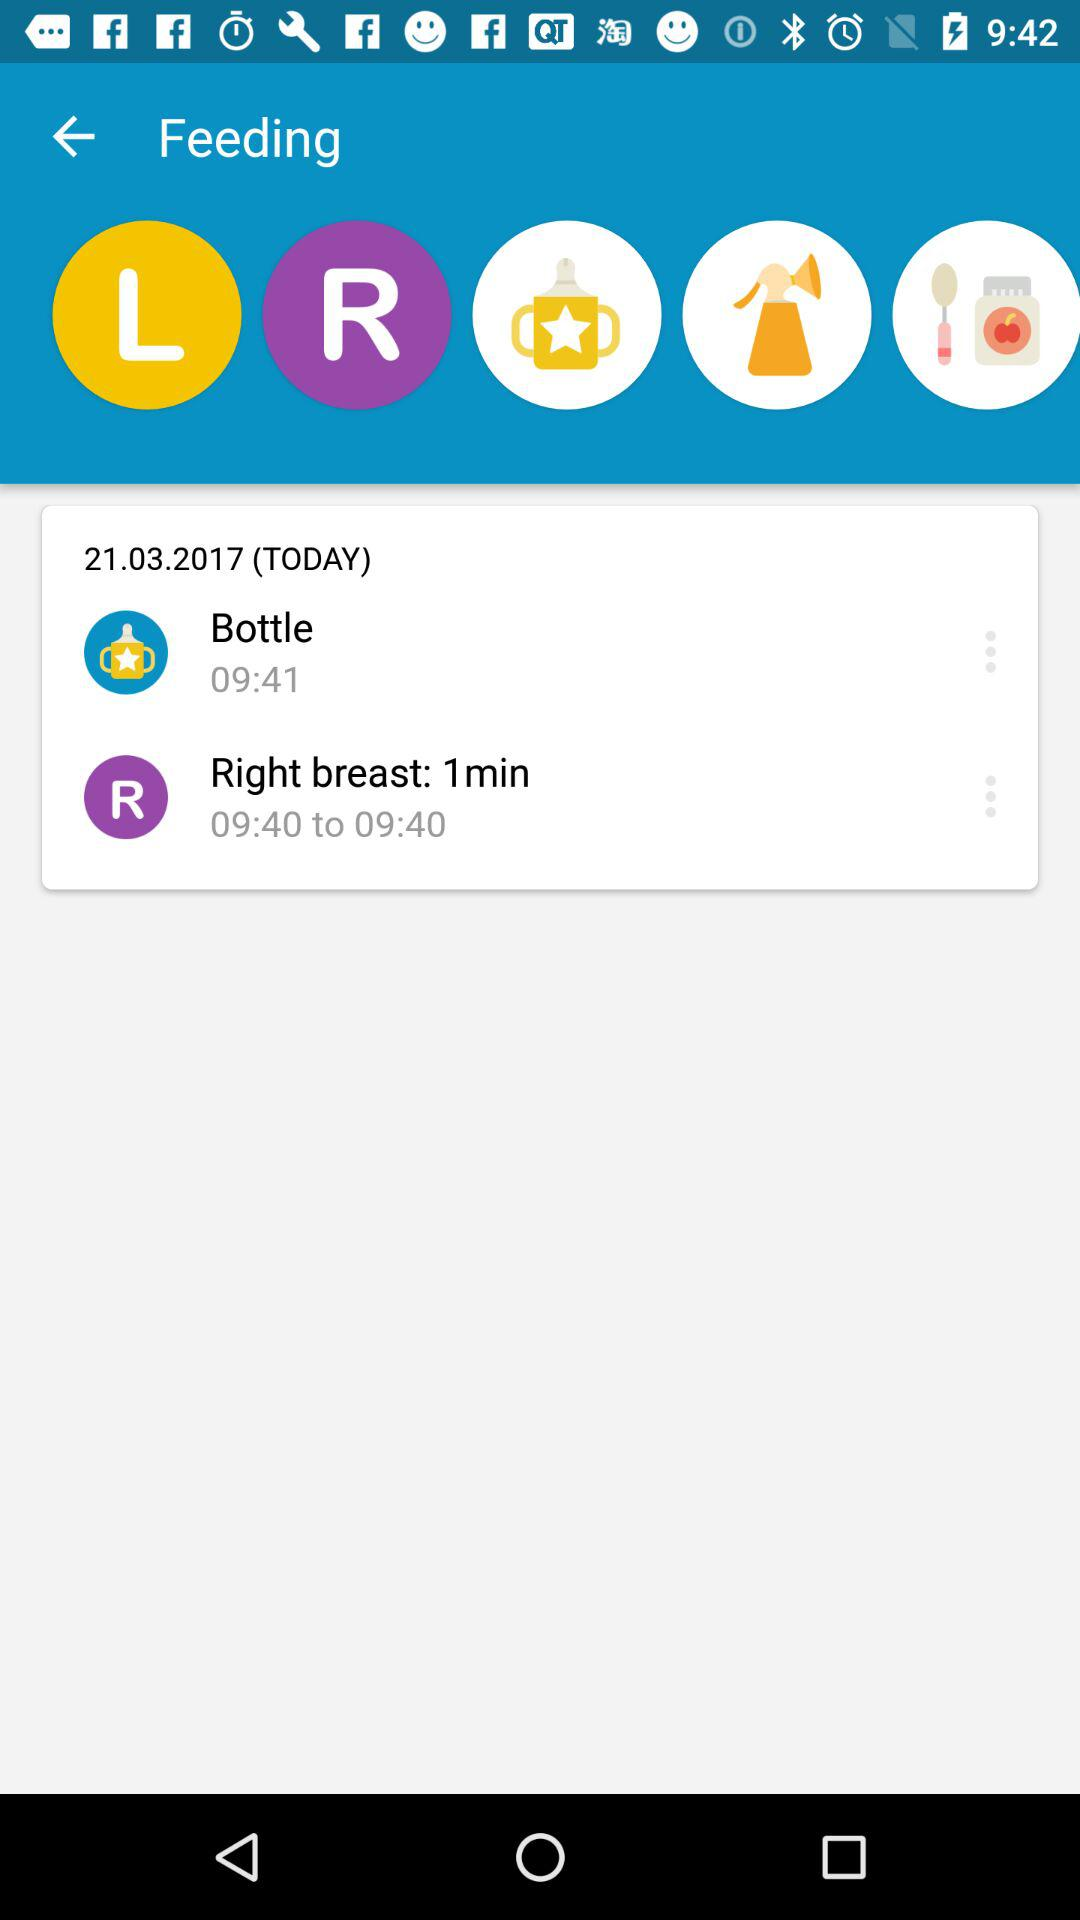How many feedings were there in total?
Answer the question using a single word or phrase. 2 